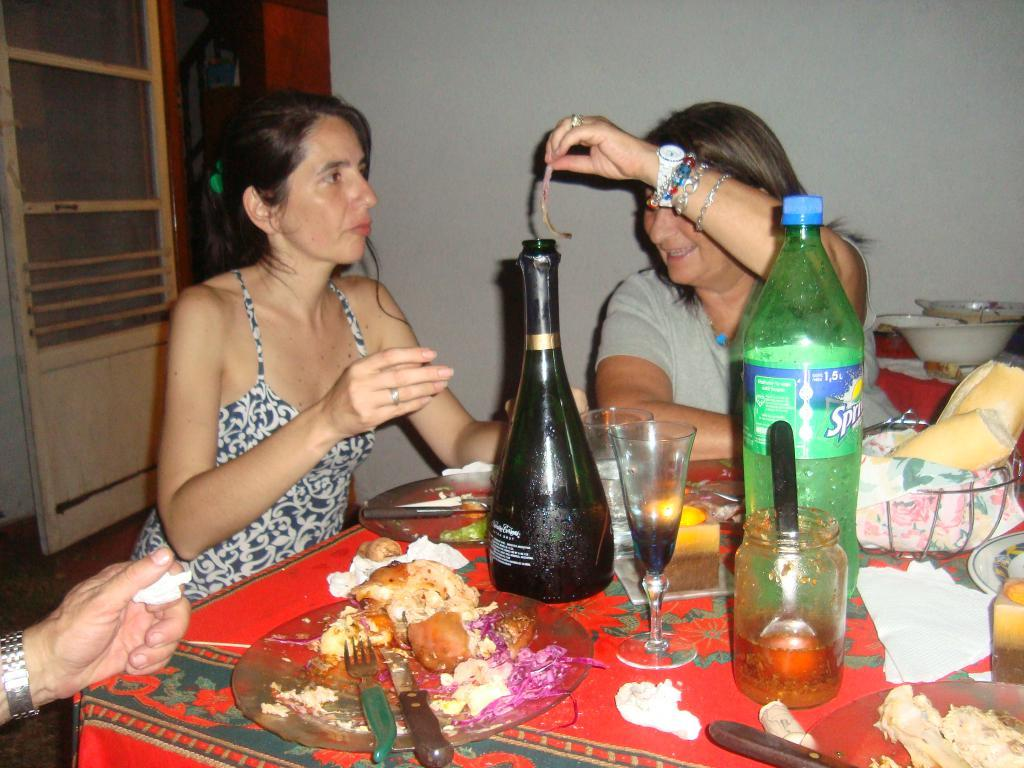Provide a one-sentence caption for the provided image. A group of people sit around a messy dining table with a bottle of Sprite in the middle. 